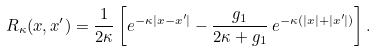<formula> <loc_0><loc_0><loc_500><loc_500>R _ { \kappa } ( x , x ^ { \prime } ) = \frac { 1 } { 2 \kappa } \left [ e ^ { - \kappa | x - x ^ { \prime } | } - \frac { g _ { 1 } } { 2 \kappa + g _ { 1 } } \, e ^ { - \kappa ( | x | + | x ^ { \prime } | ) } \right ] .</formula> 